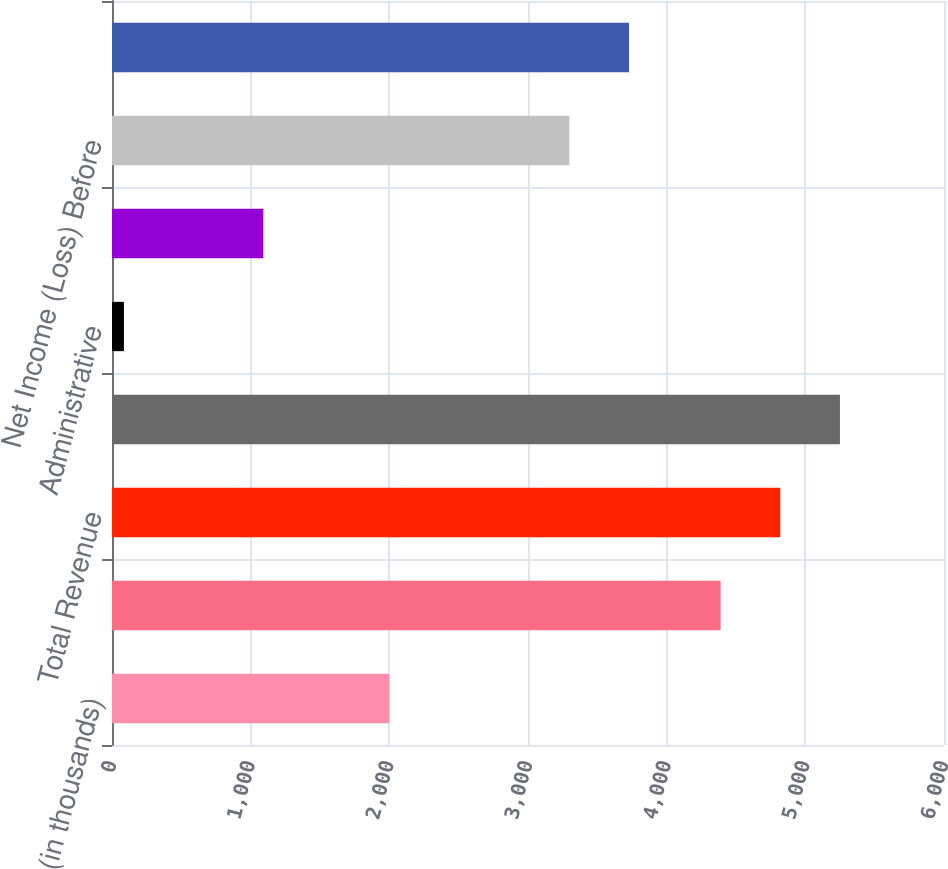Convert chart to OTSL. <chart><loc_0><loc_0><loc_500><loc_500><bar_chart><fcel>(in thousands)<fcel>Other income<fcel>Total Revenue<fcel>Gross Margin<fcel>Administrative<fcel>Total Expenses<fcel>Net Income (Loss) Before<fcel>Net Income (Loss)<nl><fcel>2000<fcel>4389<fcel>4819.3<fcel>5249.6<fcel>86<fcel>1091<fcel>3298<fcel>3728.3<nl></chart> 